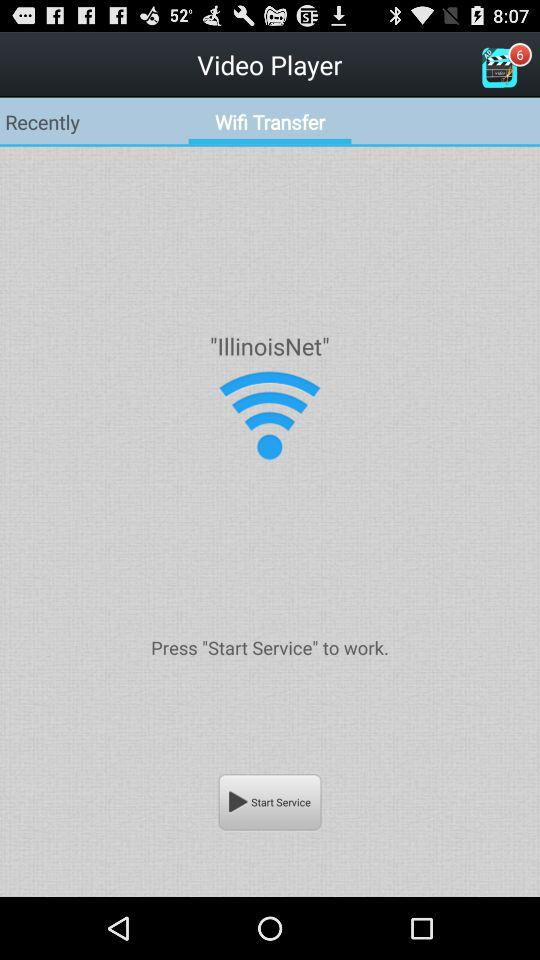Which tab is selected? The selected tab is "Wifi Transfer". 